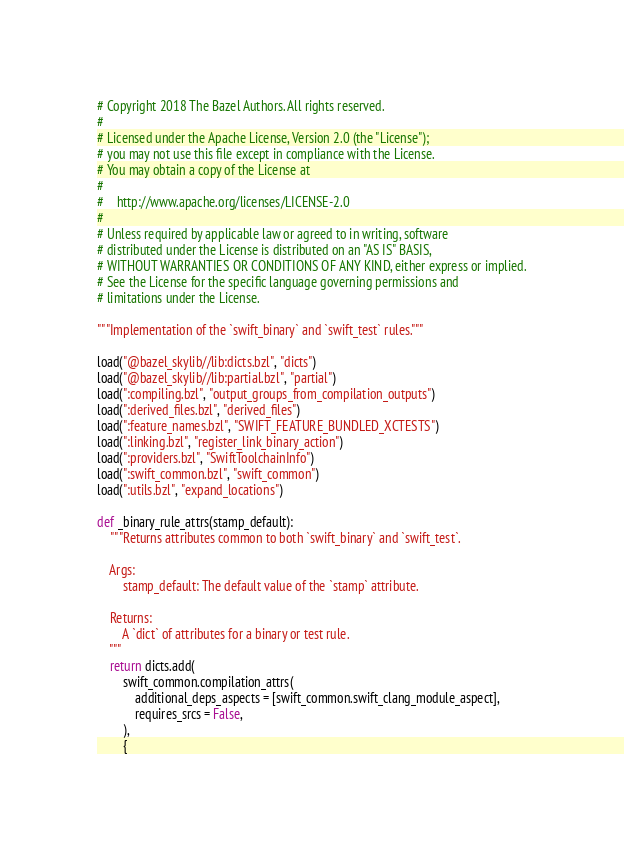<code> <loc_0><loc_0><loc_500><loc_500><_Python_># Copyright 2018 The Bazel Authors. All rights reserved.
#
# Licensed under the Apache License, Version 2.0 (the "License");
# you may not use this file except in compliance with the License.
# You may obtain a copy of the License at
#
#    http://www.apache.org/licenses/LICENSE-2.0
#
# Unless required by applicable law or agreed to in writing, software
# distributed under the License is distributed on an "AS IS" BASIS,
# WITHOUT WARRANTIES OR CONDITIONS OF ANY KIND, either express or implied.
# See the License for the specific language governing permissions and
# limitations under the License.

"""Implementation of the `swift_binary` and `swift_test` rules."""

load("@bazel_skylib//lib:dicts.bzl", "dicts")
load("@bazel_skylib//lib:partial.bzl", "partial")
load(":compiling.bzl", "output_groups_from_compilation_outputs")
load(":derived_files.bzl", "derived_files")
load(":feature_names.bzl", "SWIFT_FEATURE_BUNDLED_XCTESTS")
load(":linking.bzl", "register_link_binary_action")
load(":providers.bzl", "SwiftToolchainInfo")
load(":swift_common.bzl", "swift_common")
load(":utils.bzl", "expand_locations")

def _binary_rule_attrs(stamp_default):
    """Returns attributes common to both `swift_binary` and `swift_test`.

    Args:
        stamp_default: The default value of the `stamp` attribute.

    Returns:
        A `dict` of attributes for a binary or test rule.
    """
    return dicts.add(
        swift_common.compilation_attrs(
            additional_deps_aspects = [swift_common.swift_clang_module_aspect],
            requires_srcs = False,
        ),
        {</code> 